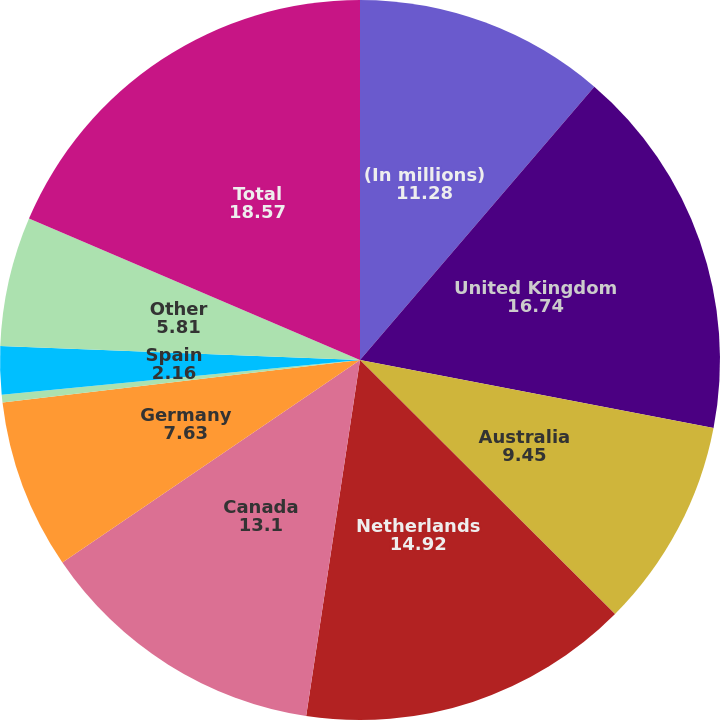Convert chart. <chart><loc_0><loc_0><loc_500><loc_500><pie_chart><fcel>(In millions)<fcel>United Kingdom<fcel>Australia<fcel>Netherlands<fcel>Canada<fcel>Germany<fcel>France<fcel>Spain<fcel>Other<fcel>Total<nl><fcel>11.28%<fcel>16.74%<fcel>9.45%<fcel>14.92%<fcel>13.1%<fcel>7.63%<fcel>0.34%<fcel>2.16%<fcel>5.81%<fcel>18.57%<nl></chart> 